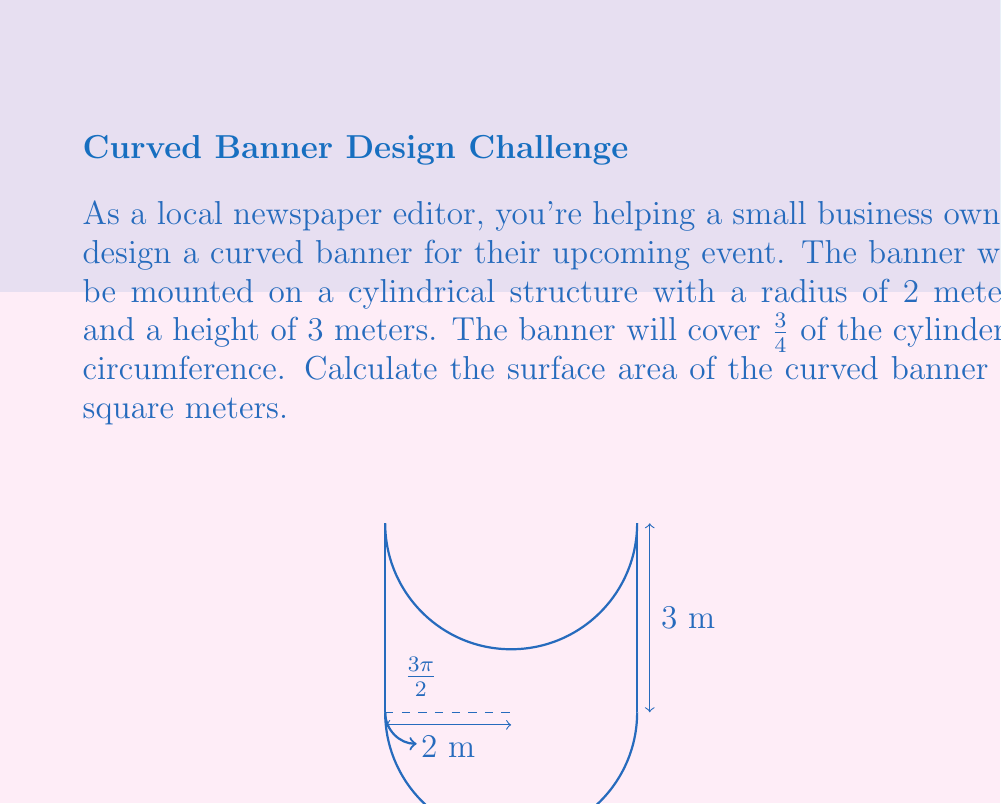Show me your answer to this math problem. Let's approach this step-by-step:

1) The surface area of a cylinder is given by the formula:
   $$A = 2\pi rh$$
   where $r$ is the radius and $h$ is the height.

2) However, we only need 3/4 of the circumference, so we'll multiply by $\frac{3}{4}$:
   $$A = \frac{3}{4} \cdot 2\pi rh$$

3) We're given:
   $r = 2$ meters
   $h = 3$ meters

4) Let's substitute these values:
   $$A = \frac{3}{4} \cdot 2\pi \cdot 2 \cdot 3$$

5) Simplify:
   $$A = \frac{3}{4} \cdot 4\pi \cdot 3$$
   $$A = 3\pi \cdot 3$$
   $$A = 9\pi$$

6) To get the final answer in square meters, we can leave it as $9\pi$ or calculate the approximate value:
   $$A \approx 9 \cdot 3.14159 \approx 28.27431$$

Therefore, the surface area of the curved banner is $9\pi$ square meters or approximately 28.27 square meters.
Answer: $9\pi$ m² (≈ 28.27 m²) 